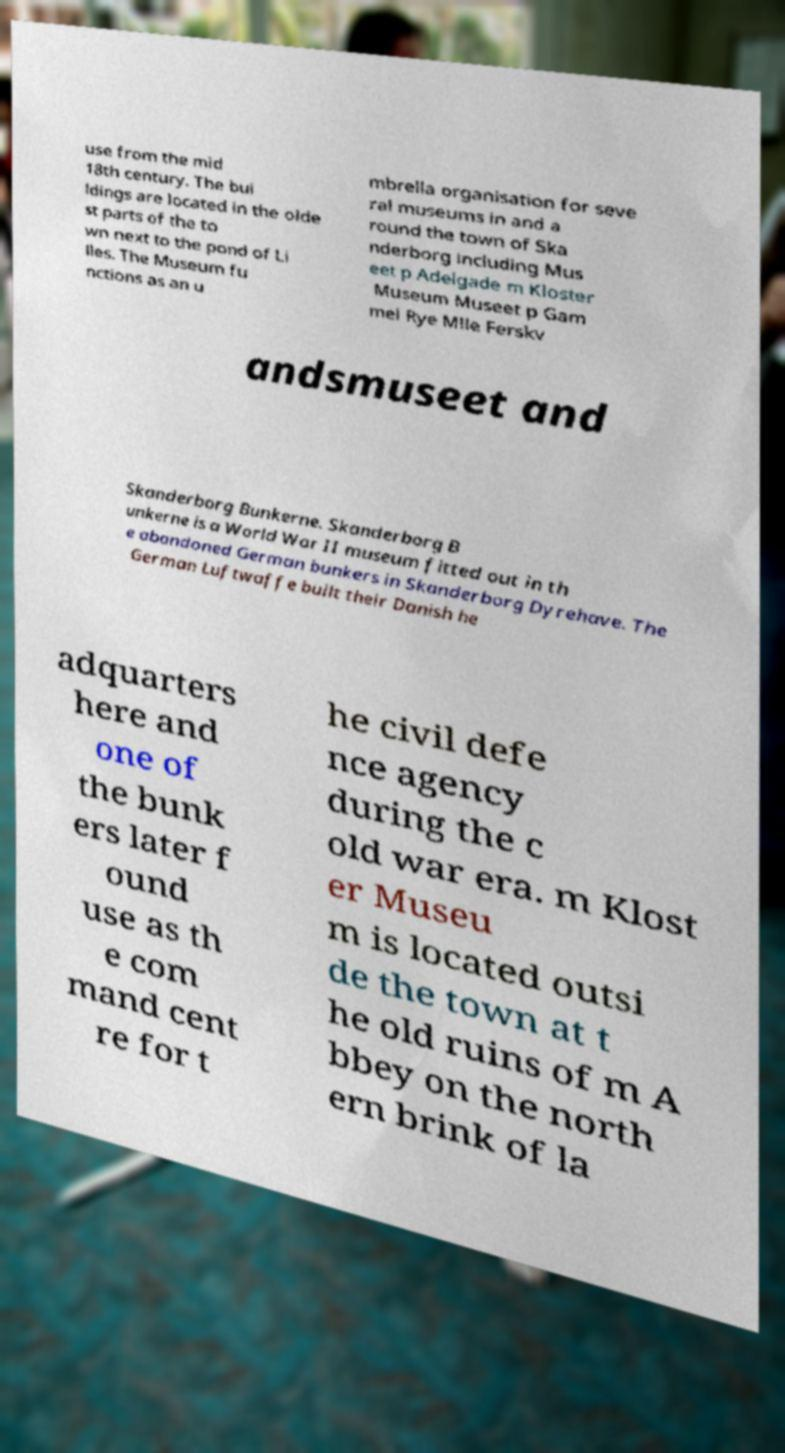For documentation purposes, I need the text within this image transcribed. Could you provide that? use from the mid 18th century. The bui ldings are located in the olde st parts of the to wn next to the pond of Li lles. The Museum fu nctions as an u mbrella organisation for seve ral museums in and a round the town of Ska nderborg including Mus eet p Adelgade m Kloster Museum Museet p Gam mel Rye Mlle Ferskv andsmuseet and Skanderborg Bunkerne. Skanderborg B unkerne is a World War II museum fitted out in th e abandoned German bunkers in Skanderborg Dyrehave. The German Luftwaffe built their Danish he adquarters here and one of the bunk ers later f ound use as th e com mand cent re for t he civil defe nce agency during the c old war era. m Klost er Museu m is located outsi de the town at t he old ruins of m A bbey on the north ern brink of la 